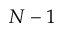<formula> <loc_0><loc_0><loc_500><loc_500>N - 1</formula> 